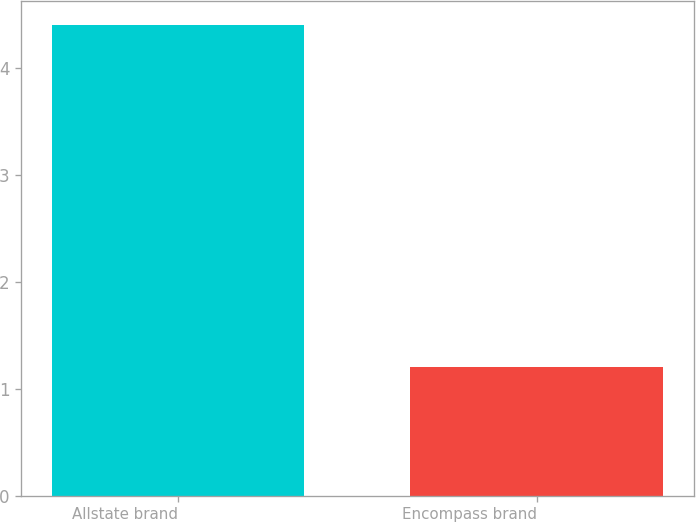Convert chart. <chart><loc_0><loc_0><loc_500><loc_500><bar_chart><fcel>Allstate brand<fcel>Encompass brand<nl><fcel>4.4<fcel>1.2<nl></chart> 